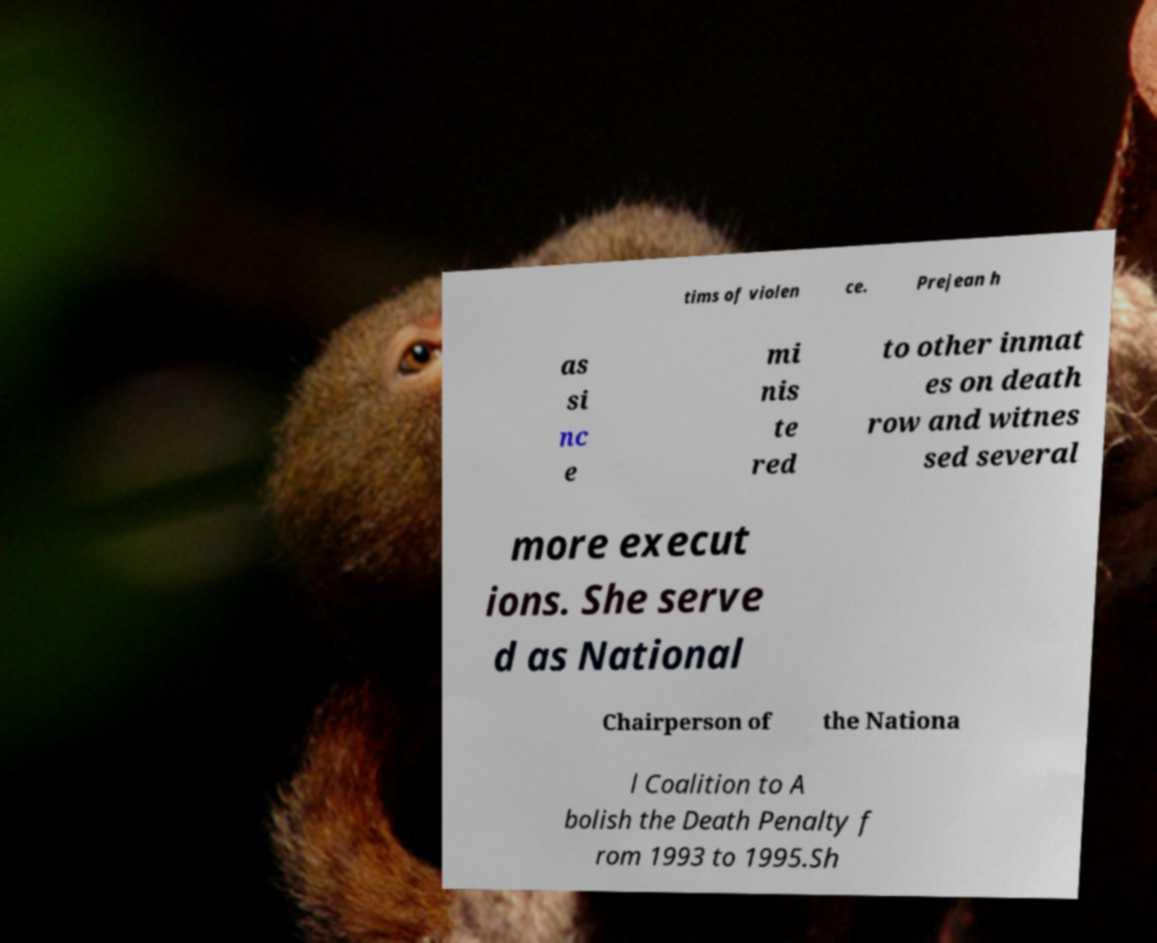Please read and relay the text visible in this image. What does it say? tims of violen ce. Prejean h as si nc e mi nis te red to other inmat es on death row and witnes sed several more execut ions. She serve d as National Chairperson of the Nationa l Coalition to A bolish the Death Penalty f rom 1993 to 1995.Sh 